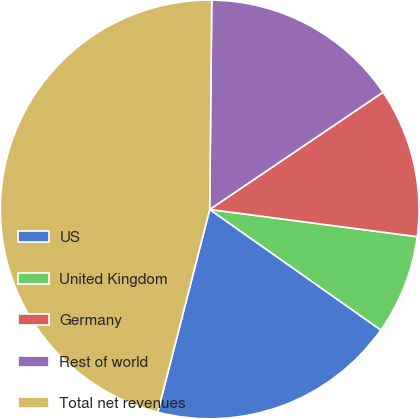Convert chart to OTSL. <chart><loc_0><loc_0><loc_500><loc_500><pie_chart><fcel>US<fcel>United Kingdom<fcel>Germany<fcel>Rest of world<fcel>Total net revenues<nl><fcel>19.23%<fcel>7.69%<fcel>11.54%<fcel>15.38%<fcel>46.16%<nl></chart> 